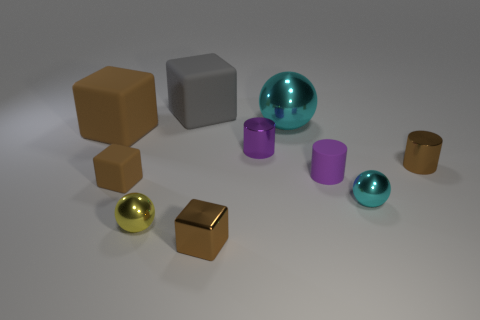Subtract all tiny balls. How many balls are left? 1 Subtract all spheres. How many objects are left? 7 Subtract 2 spheres. How many spheres are left? 1 Subtract 0 blue cubes. How many objects are left? 10 Subtract all red cylinders. Subtract all cyan cubes. How many cylinders are left? 3 Subtract all green balls. How many gray blocks are left? 1 Subtract all gray objects. Subtract all small blue rubber objects. How many objects are left? 9 Add 6 small brown metal cubes. How many small brown metal cubes are left? 7 Add 9 small cyan things. How many small cyan things exist? 10 Subtract all gray blocks. How many blocks are left? 3 